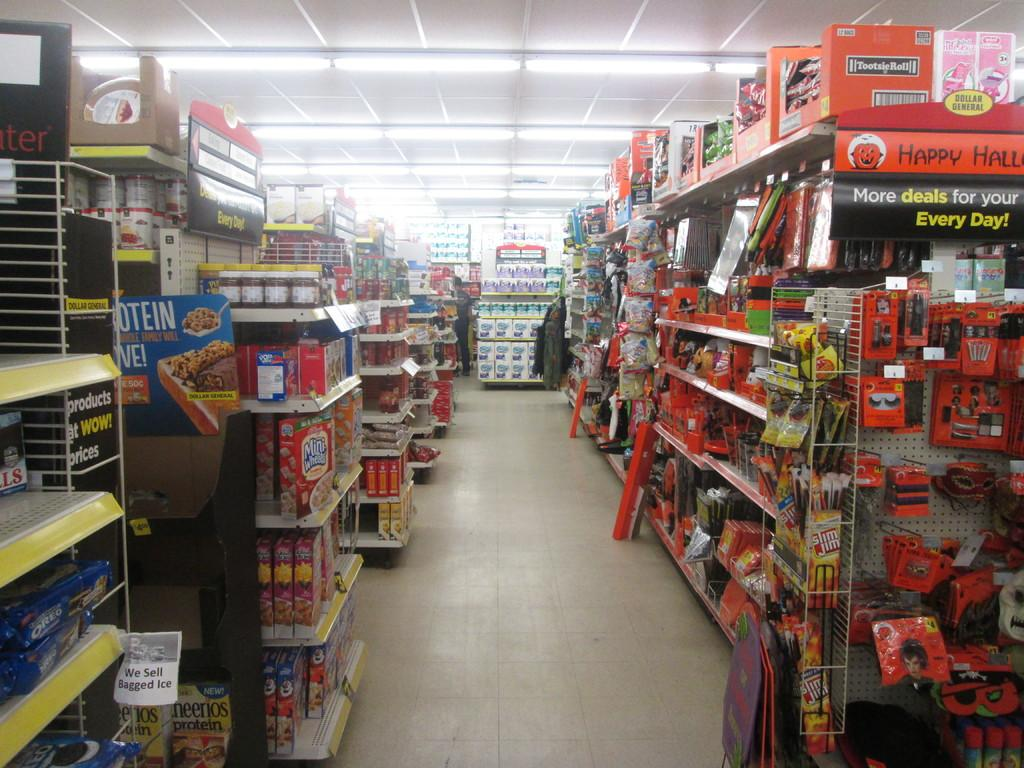What type of establishment is shown in the image? There is a grocery store in the image. What can be seen on the sides of the image? There are cracks on both the right and left sides of the image. Where are the lights located in the image? The lights are at the top side of the image. What type of engine can be seen powering the grocery store in the image? There is no engine visible in the image, as it is a grocery store and not a vehicle or machine. 